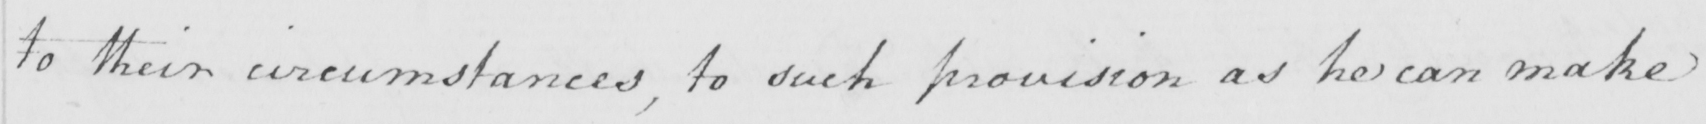What text is written in this handwritten line? to their circumstances , to such provision as he can make 